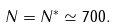Convert formula to latex. <formula><loc_0><loc_0><loc_500><loc_500>N = N ^ { * } \simeq 7 0 0 .</formula> 